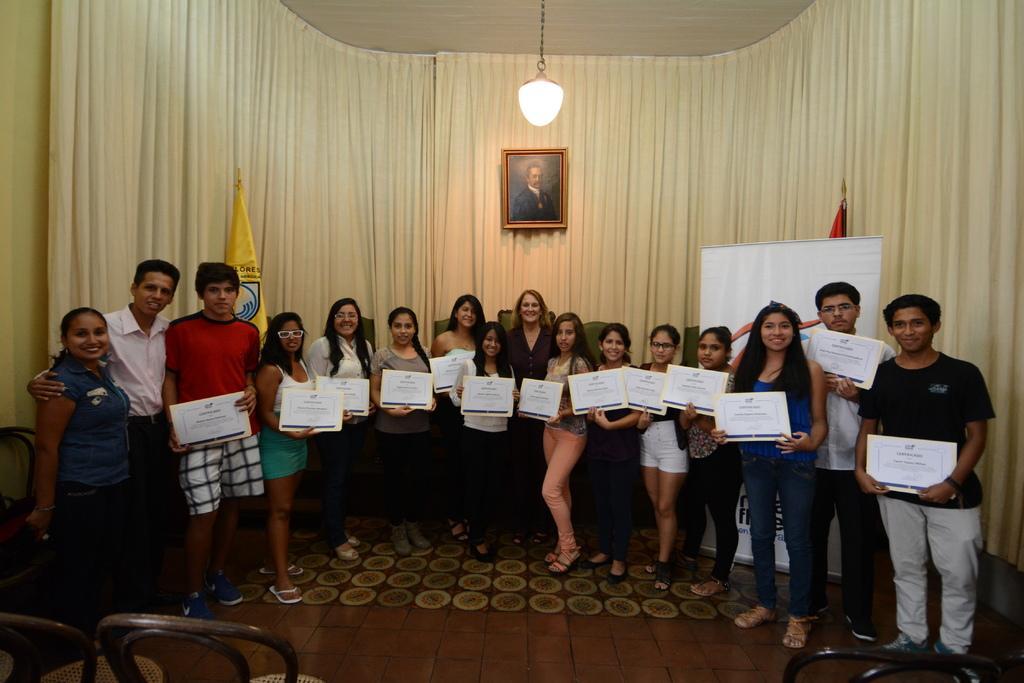In one or two sentences, can you explain what this image depicts? In the foreground of this image, there are people standing on the floor holding boards. At the bottom, there are chairs. In the background, there are flags, a board, curtain, frame and a light hanging. 